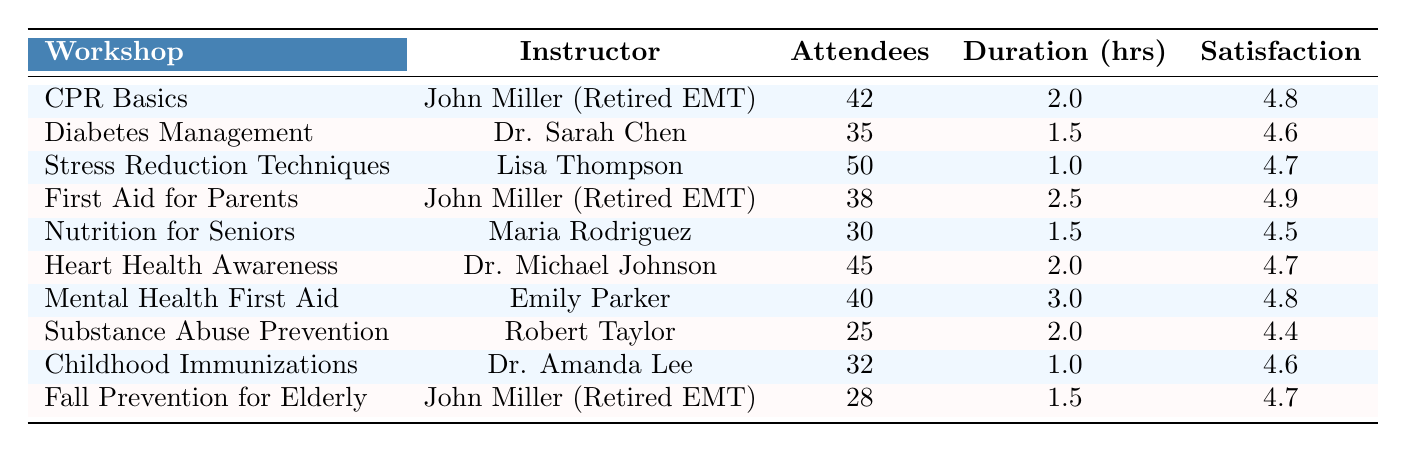What is the most attended workshop? The workshop with the highest number of attendees is "Stress Reduction Techniques," which has 50 attendees.
Answer: Stress Reduction Techniques How many workshops did John Miller instruct? John Miller instructed three workshops: "CPR Basics," "First Aid for Parents," and "Fall Prevention for Elderly."
Answer: Three What is the average satisfaction score of the workshops? The satisfaction scores are 4.8, 4.6, 4.7, 4.9, 4.5, 4.7, 4.8, 4.4, 4.6, and 4.7. Summing these scores gives 47.7. Dividing by 10 (the total number of workshops) results in an average satisfaction score of 4.77.
Answer: 4.77 Is the duration of the "Diabetes Management" workshop longer than the "Childhood Immunizations" workshop? The "Diabetes Management" workshop lasts 1.5 hours, while the "Childhood Immunizations" workshop lasts 1 hour. Since 1.5 is greater than 1, the statement is true.
Answer: Yes What is the total number of attendees for all workshops instructed by John Miller? John Miller has 42 attendees for "CPR Basics," 38 for "First Aid for Parents," and 28 for "Fall Prevention for Elderly." Summing these gives 42 + 38 + 28 = 108.
Answer: 108 What is the difference in satisfaction score between the highest and lowest-rated workshops? The highest satisfaction score is 4.9 from "First Aid for Parents," and the lowest is 4.4 from "Substance Abuse Prevention." The difference is 4.9 - 4.4 = 0.5.
Answer: 0.5 Which workshop has the lowest number of attendees? The workshop with the fewest attendees is "Substance Abuse Prevention," which has 25 attendees.
Answer: Substance Abuse Prevention How many workshops last longer than 2 hours? The workshops "First Aid for Parents" (2.5 hours) and "Mental Health First Aid" (3 hours) last longer than 2 hours. This gives a total of 2 workshops.
Answer: 2 What percentage of workshops received a satisfaction score of 4.7 or higher? The workshops with scores of 4.7 or higher are: "CPR Basics" (4.8), "Stress Reduction Techniques" (4.7), "First Aid for Parents" (4.9), "Heart Health Awareness" (4.7), and "Mental Health First Aid" (4.8). That is 5 out of 10 workshops, which equals 50%.
Answer: 50% Is there a workshop with both high attendance and a high satisfaction score? "Stress Reduction Techniques" has 50 attendees and a satisfaction score of 4.7. It meets the criteria for high attendance (above 40) and high satisfaction (above 4.5).
Answer: Yes 